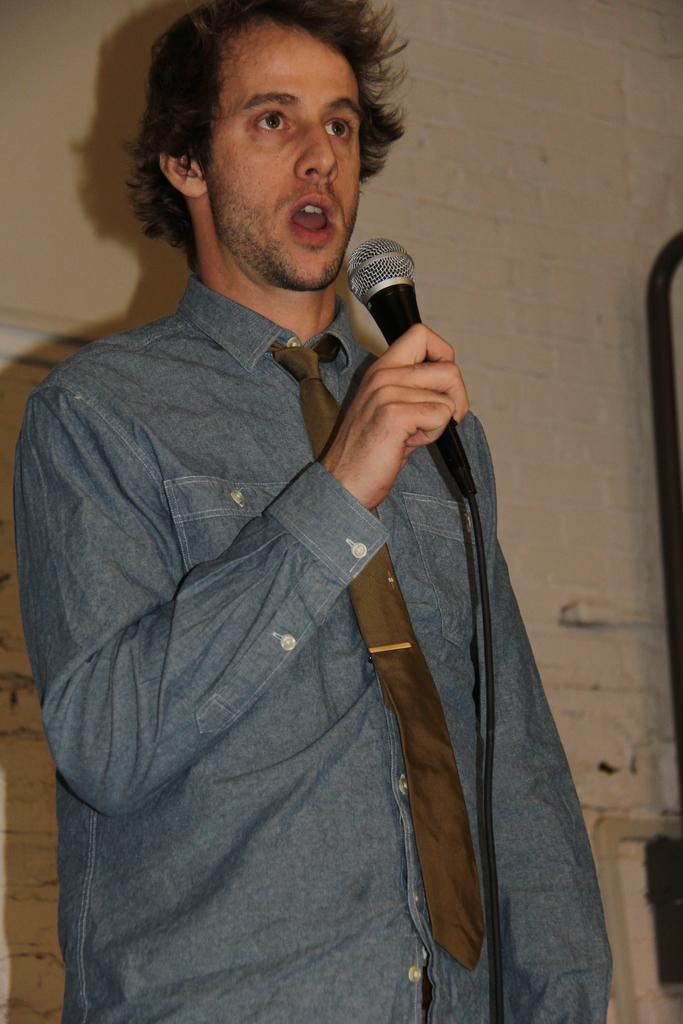Who is the main subject in the image? There is a man in the image. What is the man doing in the image? The man is speaking into a microphone. How is the microphone being held by the man? The microphone is held in his hand. What can be seen on the man's clothing in the image? The man is wearing a tie. How many brothers does the man have in the image? There is no information about the man's brothers in the image. Can you describe the garden in the image? There is no garden present in the image. 